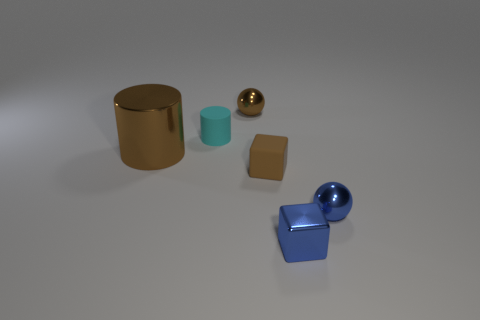There is a tiny thing that is the same material as the small brown block; what is its shape?
Provide a succinct answer. Cylinder. What number of other objects are there of the same shape as the tiny cyan matte thing?
Provide a short and direct response. 1. How many tiny rubber blocks are to the right of the metallic cube?
Offer a very short reply. 0. Do the brown metallic thing that is behind the large object and the rubber object that is on the right side of the small cyan cylinder have the same size?
Your answer should be very brief. Yes. How many other things are the same size as the metal block?
Your answer should be compact. 4. What material is the small ball behind the brown object that is left of the object that is behind the small cyan cylinder?
Give a very brief answer. Metal. Does the blue metallic ball have the same size as the ball behind the tiny blue metal sphere?
Provide a succinct answer. Yes. How big is the shiny object that is to the left of the blue cube and to the right of the large cylinder?
Your response must be concise. Small. Is there another thing of the same color as the large metal thing?
Ensure brevity in your answer.  Yes. There is a small shiny object in front of the small ball on the right side of the tiny brown metallic object; what color is it?
Provide a short and direct response. Blue. 